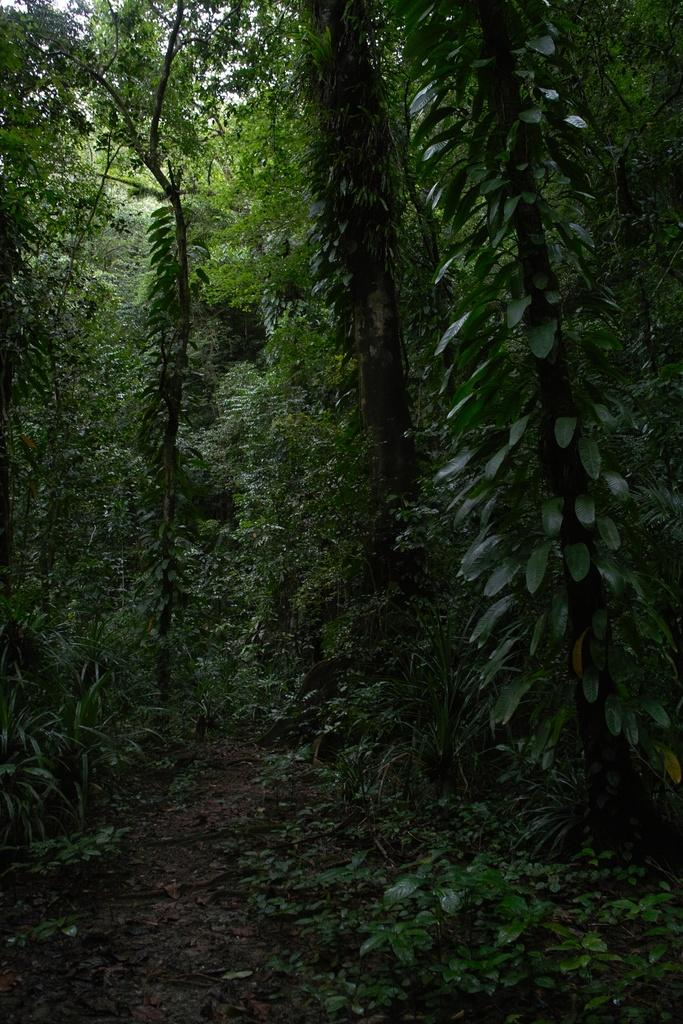Where was the picture taken? The picture was clicked outside. What can be seen in the foreground of the image? There are plants and the ground visible in the foreground of the image. What is visible in the background of the image? There are trees in the background of the image. What type of mask is being worn by the plant in the image? There are no masks present in the image, as it features plants and trees in an outdoor setting. 